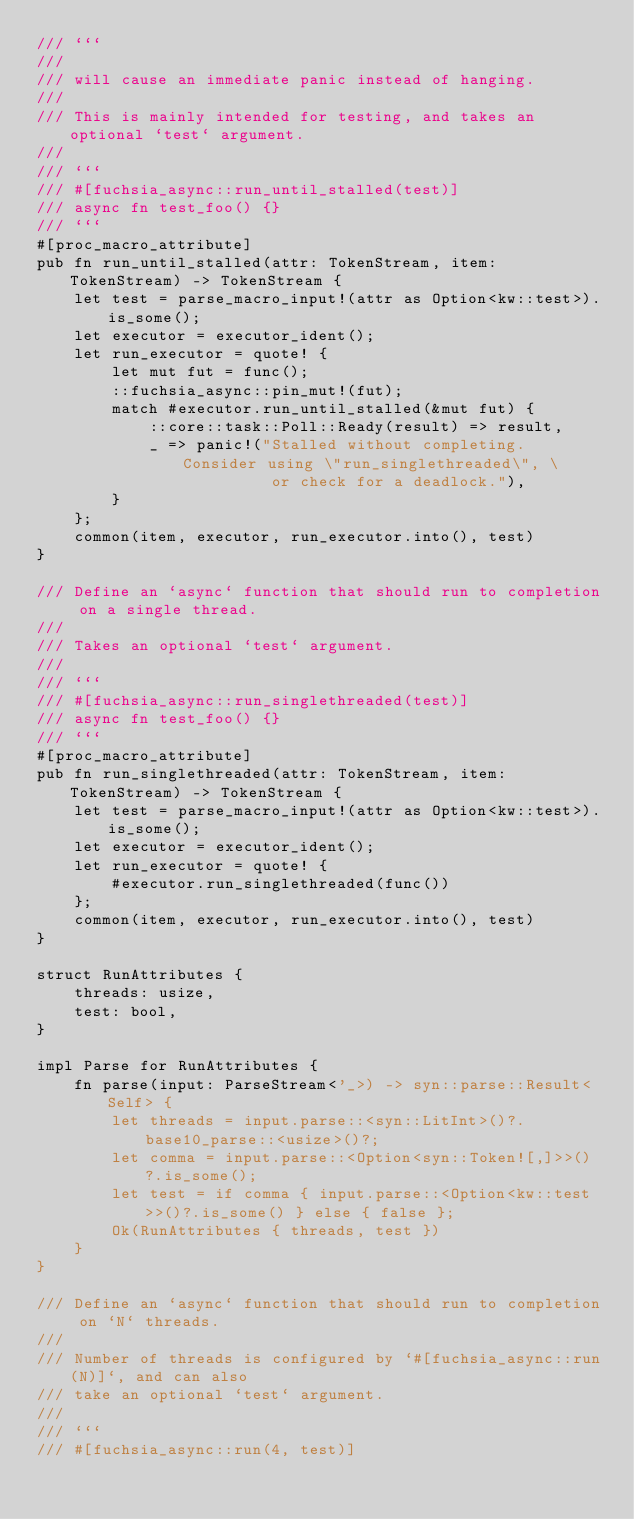<code> <loc_0><loc_0><loc_500><loc_500><_Rust_>/// ```
///
/// will cause an immediate panic instead of hanging.
///
/// This is mainly intended for testing, and takes an optional `test` argument.
///
/// ```
/// #[fuchsia_async::run_until_stalled(test)]
/// async fn test_foo() {}
/// ```
#[proc_macro_attribute]
pub fn run_until_stalled(attr: TokenStream, item: TokenStream) -> TokenStream {
    let test = parse_macro_input!(attr as Option<kw::test>).is_some();
    let executor = executor_ident();
    let run_executor = quote! {
        let mut fut = func();
        ::fuchsia_async::pin_mut!(fut);
        match #executor.run_until_stalled(&mut fut) {
            ::core::task::Poll::Ready(result) => result,
            _ => panic!("Stalled without completing. Consider using \"run_singlethreaded\", \
                         or check for a deadlock."),
        }
    };
    common(item, executor, run_executor.into(), test)
}

/// Define an `async` function that should run to completion on a single thread.
///
/// Takes an optional `test` argument.
///
/// ```
/// #[fuchsia_async::run_singlethreaded(test)]
/// async fn test_foo() {}
/// ```
#[proc_macro_attribute]
pub fn run_singlethreaded(attr: TokenStream, item: TokenStream) -> TokenStream {
    let test = parse_macro_input!(attr as Option<kw::test>).is_some();
    let executor = executor_ident();
    let run_executor = quote! {
        #executor.run_singlethreaded(func())
    };
    common(item, executor, run_executor.into(), test)
}

struct RunAttributes {
    threads: usize,
    test: bool,
}

impl Parse for RunAttributes {
    fn parse(input: ParseStream<'_>) -> syn::parse::Result<Self> {
        let threads = input.parse::<syn::LitInt>()?.base10_parse::<usize>()?;
        let comma = input.parse::<Option<syn::Token![,]>>()?.is_some();
        let test = if comma { input.parse::<Option<kw::test>>()?.is_some() } else { false };
        Ok(RunAttributes { threads, test })
    }
}

/// Define an `async` function that should run to completion on `N` threads.
///
/// Number of threads is configured by `#[fuchsia_async::run(N)]`, and can also
/// take an optional `test` argument.
///
/// ```
/// #[fuchsia_async::run(4, test)]</code> 